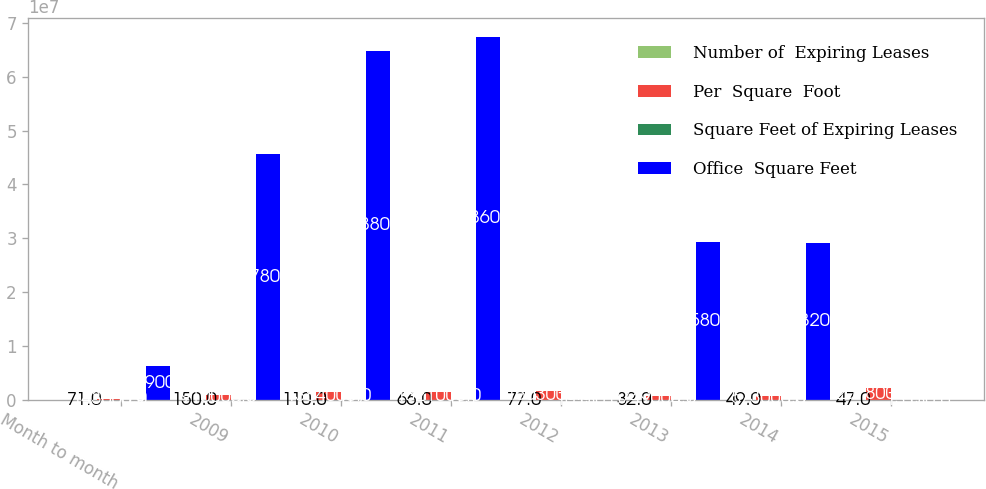Convert chart. <chart><loc_0><loc_0><loc_500><loc_500><stacked_bar_chart><ecel><fcel>Month to month<fcel>2009<fcel>2010<fcel>2011<fcel>2012<fcel>2013<fcel>2014<fcel>2015<nl><fcel>Number of  Expiring Leases<fcel>71<fcel>150<fcel>110<fcel>66<fcel>77<fcel>32<fcel>49<fcel>47<nl><fcel>Per  Square  Foot<fcel>143000<fcel>910000<fcel>1.384e+06<fcel>1.321e+06<fcel>1.603e+06<fcel>749000<fcel>573000<fcel>2.078e+06<nl><fcel>Square Feet of Expiring Leases<fcel>0.9<fcel>5.7<fcel>8.7<fcel>8.3<fcel>10<fcel>4.7<fcel>3.6<fcel>13<nl><fcel>Office  Square Feet<fcel>6.249e+06<fcel>4.5678e+07<fcel>6.4788e+07<fcel>6.7486e+07<fcel>130<fcel>2.9358e+07<fcel>2.9032e+07<fcel>130<nl></chart> 